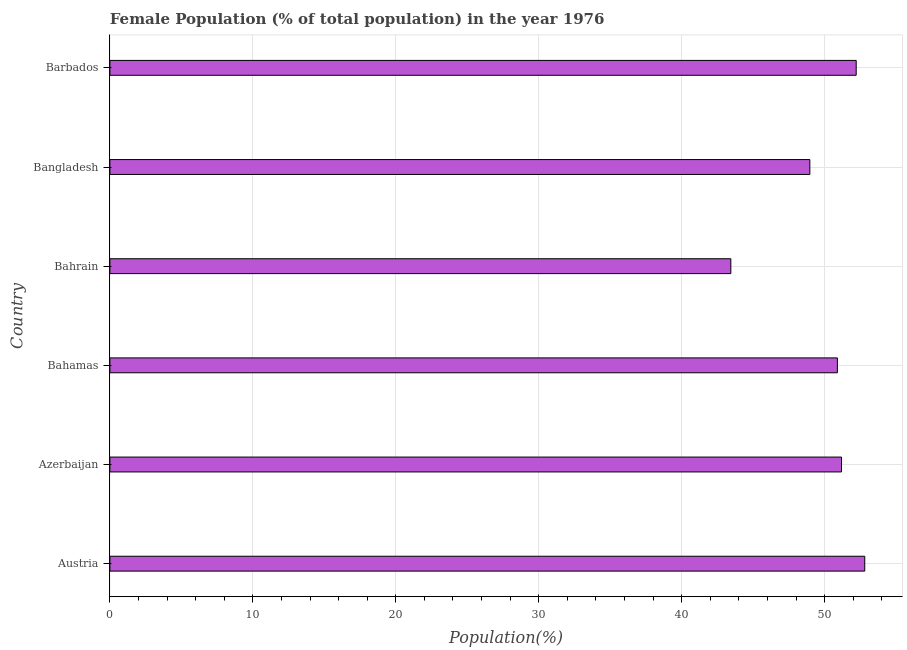Does the graph contain any zero values?
Your answer should be very brief. No. Does the graph contain grids?
Your answer should be compact. Yes. What is the title of the graph?
Provide a short and direct response. Female Population (% of total population) in the year 1976. What is the label or title of the X-axis?
Make the answer very short. Population(%). What is the female population in Barbados?
Offer a very short reply. 52.21. Across all countries, what is the maximum female population?
Your response must be concise. 52.81. Across all countries, what is the minimum female population?
Your response must be concise. 43.44. In which country was the female population minimum?
Your answer should be compact. Bahrain. What is the sum of the female population?
Your response must be concise. 299.49. What is the difference between the female population in Bahrain and Bangladesh?
Ensure brevity in your answer.  -5.53. What is the average female population per country?
Offer a terse response. 49.91. What is the median female population?
Offer a very short reply. 51.04. In how many countries, is the female population greater than 36 %?
Give a very brief answer. 6. What is the ratio of the female population in Azerbaijan to that in Bahamas?
Provide a succinct answer. 1.01. Is the female population in Azerbaijan less than that in Bahrain?
Your answer should be compact. No. Is the difference between the female population in Azerbaijan and Bangladesh greater than the difference between any two countries?
Keep it short and to the point. No. What is the difference between the highest and the second highest female population?
Provide a short and direct response. 0.6. What is the difference between the highest and the lowest female population?
Provide a succinct answer. 9.37. Are the values on the major ticks of X-axis written in scientific E-notation?
Keep it short and to the point. No. What is the Population(%) in Austria?
Your response must be concise. 52.81. What is the Population(%) of Azerbaijan?
Provide a succinct answer. 51.18. What is the Population(%) in Bahamas?
Ensure brevity in your answer.  50.89. What is the Population(%) of Bahrain?
Provide a short and direct response. 43.44. What is the Population(%) in Bangladesh?
Give a very brief answer. 48.97. What is the Population(%) in Barbados?
Offer a terse response. 52.21. What is the difference between the Population(%) in Austria and Azerbaijan?
Provide a succinct answer. 1.63. What is the difference between the Population(%) in Austria and Bahamas?
Make the answer very short. 1.91. What is the difference between the Population(%) in Austria and Bahrain?
Your answer should be very brief. 9.37. What is the difference between the Population(%) in Austria and Bangladesh?
Provide a succinct answer. 3.84. What is the difference between the Population(%) in Austria and Barbados?
Your answer should be very brief. 0.6. What is the difference between the Population(%) in Azerbaijan and Bahamas?
Make the answer very short. 0.29. What is the difference between the Population(%) in Azerbaijan and Bahrain?
Make the answer very short. 7.74. What is the difference between the Population(%) in Azerbaijan and Bangladesh?
Offer a terse response. 2.21. What is the difference between the Population(%) in Azerbaijan and Barbados?
Your response must be concise. -1.03. What is the difference between the Population(%) in Bahamas and Bahrain?
Provide a short and direct response. 7.45. What is the difference between the Population(%) in Bahamas and Bangladesh?
Provide a succinct answer. 1.93. What is the difference between the Population(%) in Bahamas and Barbados?
Make the answer very short. -1.32. What is the difference between the Population(%) in Bahrain and Bangladesh?
Your response must be concise. -5.53. What is the difference between the Population(%) in Bahrain and Barbados?
Offer a terse response. -8.77. What is the difference between the Population(%) in Bangladesh and Barbados?
Provide a succinct answer. -3.24. What is the ratio of the Population(%) in Austria to that in Azerbaijan?
Ensure brevity in your answer.  1.03. What is the ratio of the Population(%) in Austria to that in Bahamas?
Offer a terse response. 1.04. What is the ratio of the Population(%) in Austria to that in Bahrain?
Offer a terse response. 1.22. What is the ratio of the Population(%) in Austria to that in Bangladesh?
Make the answer very short. 1.08. What is the ratio of the Population(%) in Azerbaijan to that in Bahamas?
Offer a very short reply. 1.01. What is the ratio of the Population(%) in Azerbaijan to that in Bahrain?
Ensure brevity in your answer.  1.18. What is the ratio of the Population(%) in Azerbaijan to that in Bangladesh?
Keep it short and to the point. 1.04. What is the ratio of the Population(%) in Bahamas to that in Bahrain?
Provide a short and direct response. 1.17. What is the ratio of the Population(%) in Bahamas to that in Bangladesh?
Your answer should be very brief. 1.04. What is the ratio of the Population(%) in Bahamas to that in Barbados?
Your answer should be very brief. 0.97. What is the ratio of the Population(%) in Bahrain to that in Bangladesh?
Provide a short and direct response. 0.89. What is the ratio of the Population(%) in Bahrain to that in Barbados?
Provide a succinct answer. 0.83. What is the ratio of the Population(%) in Bangladesh to that in Barbados?
Provide a succinct answer. 0.94. 